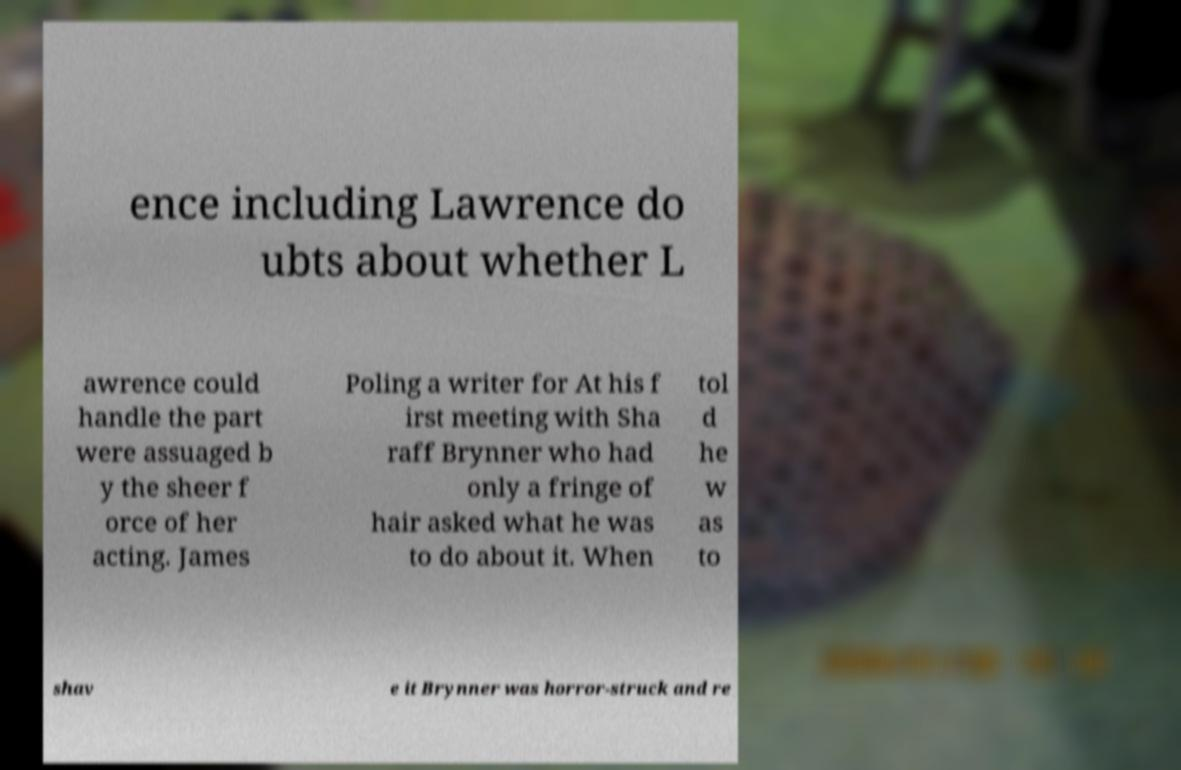Please read and relay the text visible in this image. What does it say? ence including Lawrence do ubts about whether L awrence could handle the part were assuaged b y the sheer f orce of her acting. James Poling a writer for At his f irst meeting with Sha raff Brynner who had only a fringe of hair asked what he was to do about it. When tol d he w as to shav e it Brynner was horror-struck and re 